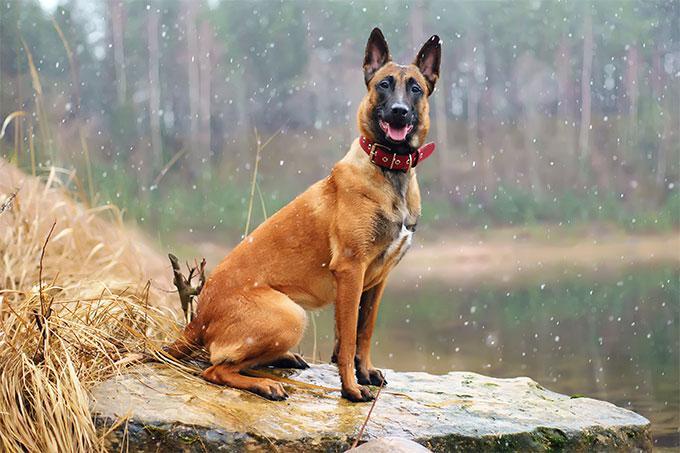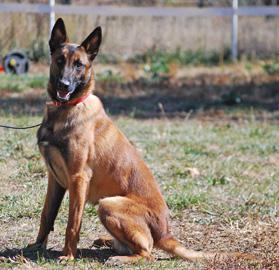The first image is the image on the left, the second image is the image on the right. Examine the images to the left and right. Is the description "There is a dog looking off to the left." accurate? Answer yes or no. No. 